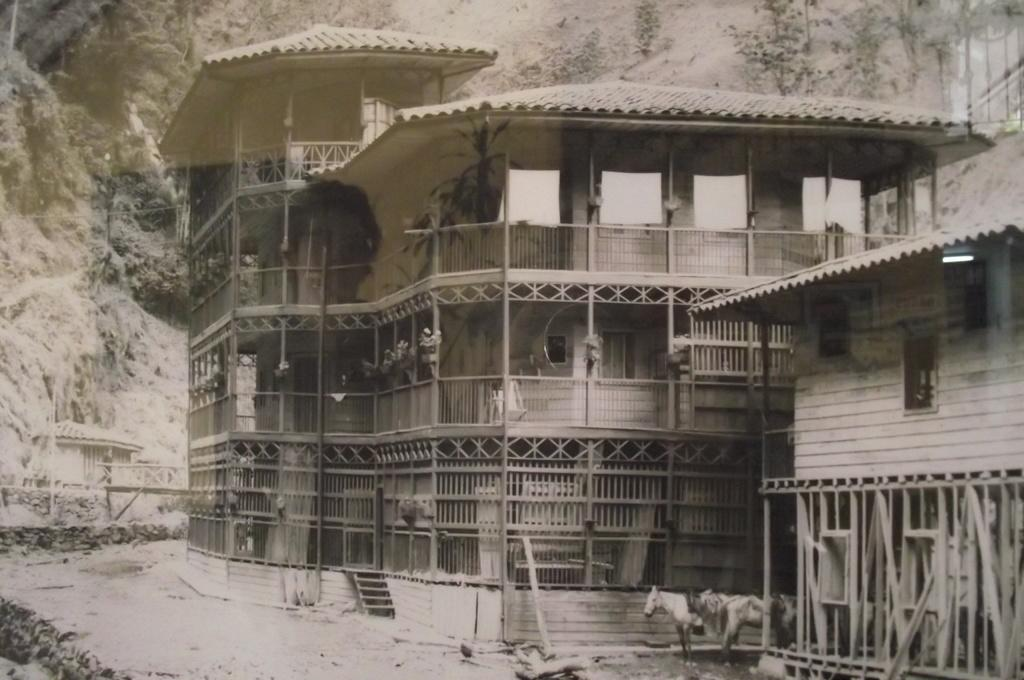What type of structure is present in the image? There is a building in the image. What animals can be seen on the ground in the image? There are horses on the ground in the image. What natural feature is visible behind the building in the image? There is a hill visible behind the building in the image. How is the image presented in terms of color? The image is black and white. What type of cabbage is being harvested at the event in the image? There is no event or cabbage present in the image. What type of destruction can be seen happening to the building in the image? There is no destruction or damage to the building in the image; it appears to be intact. 